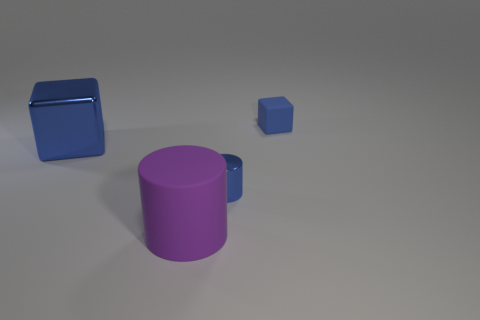What number of shiny things are behind the blue object that is behind the metallic object to the left of the big cylinder? 0 